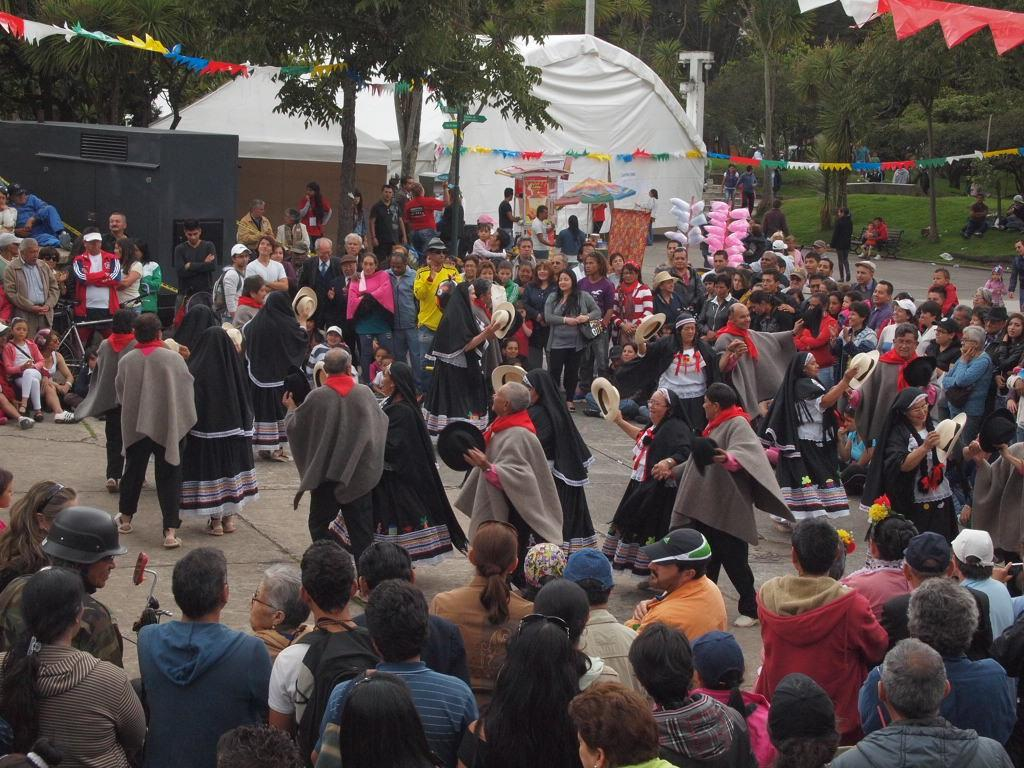What are the people in the image doing? Some people are dancing in the middle of the image. Can you describe the setting of the image? There are tents and trees in the background of the image. How many people are visible in the image? The number of people is not specified, but there are people standing in the image. What type of bone can be seen in the image? There is no bone present in the image. What kind of waste is being disposed of in the image? There is no waste disposal activity depicted in the image. 